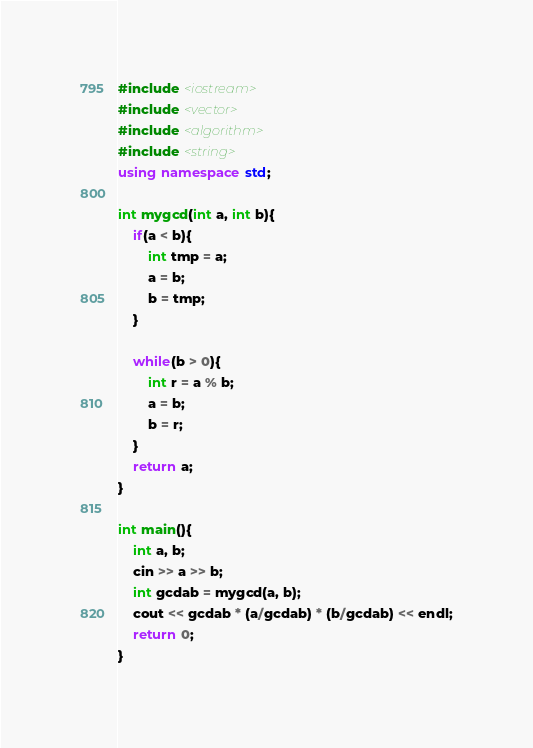<code> <loc_0><loc_0><loc_500><loc_500><_C++_>#include <iostream>
#include <vector>
#include <algorithm>
#include <string>
using namespace std;

int mygcd(int a, int b){
    if(a < b){
        int tmp = a;
        a = b;
        b = tmp;
    }

    while(b > 0){
        int r = a % b;
        a = b;
        b = r;
    }
    return a;
}

int main(){
    int a, b;
    cin >> a >> b;
    int gcdab = mygcd(a, b);
    cout << gcdab * (a/gcdab) * (b/gcdab) << endl;
    return 0;
}</code> 